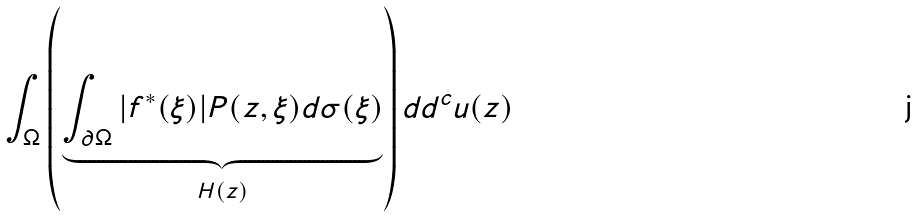Convert formula to latex. <formula><loc_0><loc_0><loc_500><loc_500>\int _ { \Omega } \left ( \underbrace { \int _ { \partial \Omega } | f ^ { * } ( \xi ) | P ( z , \xi ) d \sigma ( \xi ) } _ { H ( z ) } \right ) d d ^ { c } u ( z )</formula> 